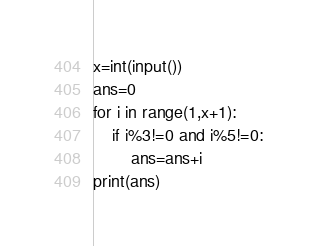Convert code to text. <code><loc_0><loc_0><loc_500><loc_500><_Python_>x=int(input())
ans=0
for i in range(1,x+1):
	if i%3!=0 and i%5!=0:
		ans=ans+i
print(ans)	</code> 